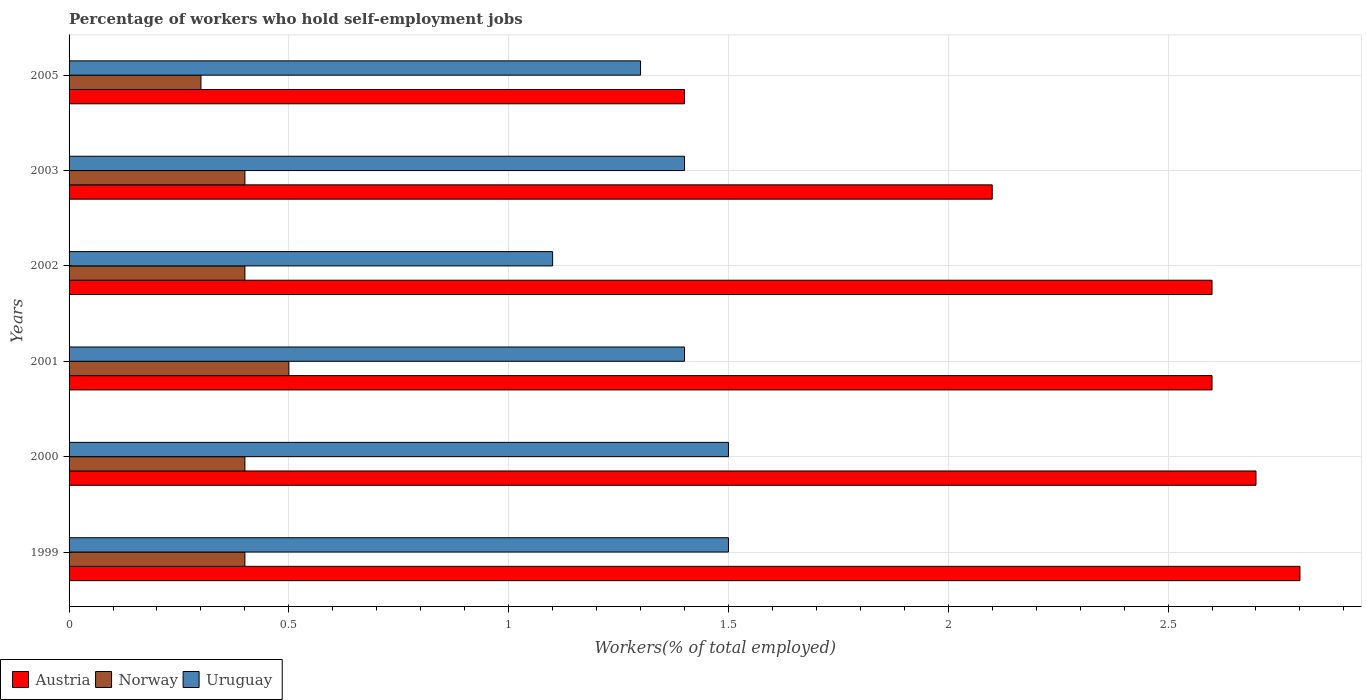How many different coloured bars are there?
Ensure brevity in your answer.  3. Are the number of bars on each tick of the Y-axis equal?
Your response must be concise. Yes. How many bars are there on the 2nd tick from the top?
Offer a terse response. 3. How many bars are there on the 3rd tick from the bottom?
Your answer should be compact. 3. What is the percentage of self-employed workers in Norway in 2002?
Offer a very short reply. 0.4. Across all years, what is the maximum percentage of self-employed workers in Norway?
Make the answer very short. 0.5. Across all years, what is the minimum percentage of self-employed workers in Uruguay?
Your answer should be very brief. 1.1. In which year was the percentage of self-employed workers in Austria maximum?
Make the answer very short. 1999. In which year was the percentage of self-employed workers in Austria minimum?
Give a very brief answer. 2005. What is the total percentage of self-employed workers in Austria in the graph?
Your answer should be compact. 14.2. What is the difference between the percentage of self-employed workers in Uruguay in 2001 and that in 2005?
Provide a succinct answer. 0.1. What is the difference between the percentage of self-employed workers in Norway in 2005 and the percentage of self-employed workers in Austria in 2002?
Give a very brief answer. -2.3. What is the average percentage of self-employed workers in Norway per year?
Your response must be concise. 0.4. In the year 2005, what is the difference between the percentage of self-employed workers in Norway and percentage of self-employed workers in Uruguay?
Keep it short and to the point. -1. What is the difference between the highest and the lowest percentage of self-employed workers in Uruguay?
Your response must be concise. 0.4. In how many years, is the percentage of self-employed workers in Uruguay greater than the average percentage of self-employed workers in Uruguay taken over all years?
Your answer should be very brief. 4. Is the sum of the percentage of self-employed workers in Norway in 2000 and 2001 greater than the maximum percentage of self-employed workers in Austria across all years?
Offer a very short reply. No. What does the 2nd bar from the top in 2001 represents?
Provide a short and direct response. Norway. What does the 1st bar from the bottom in 2002 represents?
Offer a very short reply. Austria. Are all the bars in the graph horizontal?
Provide a short and direct response. Yes. How many years are there in the graph?
Make the answer very short. 6. Are the values on the major ticks of X-axis written in scientific E-notation?
Make the answer very short. No. Where does the legend appear in the graph?
Give a very brief answer. Bottom left. How are the legend labels stacked?
Offer a very short reply. Horizontal. What is the title of the graph?
Your answer should be very brief. Percentage of workers who hold self-employment jobs. Does "Czech Republic" appear as one of the legend labels in the graph?
Keep it short and to the point. No. What is the label or title of the X-axis?
Give a very brief answer. Workers(% of total employed). What is the Workers(% of total employed) of Austria in 1999?
Your answer should be very brief. 2.8. What is the Workers(% of total employed) of Norway in 1999?
Keep it short and to the point. 0.4. What is the Workers(% of total employed) in Uruguay in 1999?
Give a very brief answer. 1.5. What is the Workers(% of total employed) of Austria in 2000?
Make the answer very short. 2.7. What is the Workers(% of total employed) of Norway in 2000?
Ensure brevity in your answer.  0.4. What is the Workers(% of total employed) in Austria in 2001?
Your response must be concise. 2.6. What is the Workers(% of total employed) of Norway in 2001?
Your answer should be very brief. 0.5. What is the Workers(% of total employed) in Uruguay in 2001?
Your answer should be compact. 1.4. What is the Workers(% of total employed) of Austria in 2002?
Ensure brevity in your answer.  2.6. What is the Workers(% of total employed) in Norway in 2002?
Keep it short and to the point. 0.4. What is the Workers(% of total employed) in Uruguay in 2002?
Your response must be concise. 1.1. What is the Workers(% of total employed) in Austria in 2003?
Provide a succinct answer. 2.1. What is the Workers(% of total employed) of Norway in 2003?
Provide a short and direct response. 0.4. What is the Workers(% of total employed) in Uruguay in 2003?
Give a very brief answer. 1.4. What is the Workers(% of total employed) in Austria in 2005?
Offer a very short reply. 1.4. What is the Workers(% of total employed) in Norway in 2005?
Give a very brief answer. 0.3. What is the Workers(% of total employed) in Uruguay in 2005?
Offer a very short reply. 1.3. Across all years, what is the maximum Workers(% of total employed) of Austria?
Keep it short and to the point. 2.8. Across all years, what is the maximum Workers(% of total employed) of Uruguay?
Make the answer very short. 1.5. Across all years, what is the minimum Workers(% of total employed) in Austria?
Ensure brevity in your answer.  1.4. Across all years, what is the minimum Workers(% of total employed) of Norway?
Ensure brevity in your answer.  0.3. Across all years, what is the minimum Workers(% of total employed) of Uruguay?
Ensure brevity in your answer.  1.1. What is the total Workers(% of total employed) of Austria in the graph?
Give a very brief answer. 14.2. What is the difference between the Workers(% of total employed) in Norway in 1999 and that in 2000?
Offer a terse response. 0. What is the difference between the Workers(% of total employed) of Austria in 1999 and that in 2002?
Ensure brevity in your answer.  0.2. What is the difference between the Workers(% of total employed) of Uruguay in 1999 and that in 2002?
Offer a terse response. 0.4. What is the difference between the Workers(% of total employed) of Austria in 1999 and that in 2003?
Make the answer very short. 0.7. What is the difference between the Workers(% of total employed) of Norway in 1999 and that in 2003?
Make the answer very short. 0. What is the difference between the Workers(% of total employed) of Uruguay in 1999 and that in 2005?
Provide a succinct answer. 0.2. What is the difference between the Workers(% of total employed) in Norway in 2000 and that in 2001?
Keep it short and to the point. -0.1. What is the difference between the Workers(% of total employed) in Norway in 2000 and that in 2002?
Provide a short and direct response. 0. What is the difference between the Workers(% of total employed) of Uruguay in 2000 and that in 2003?
Your answer should be very brief. 0.1. What is the difference between the Workers(% of total employed) in Austria in 2000 and that in 2005?
Provide a short and direct response. 1.3. What is the difference between the Workers(% of total employed) of Norway in 2000 and that in 2005?
Your answer should be compact. 0.1. What is the difference between the Workers(% of total employed) of Austria in 2001 and that in 2002?
Provide a succinct answer. 0. What is the difference between the Workers(% of total employed) of Norway in 2001 and that in 2002?
Give a very brief answer. 0.1. What is the difference between the Workers(% of total employed) in Austria in 2001 and that in 2005?
Your answer should be compact. 1.2. What is the difference between the Workers(% of total employed) in Austria in 2002 and that in 2003?
Your answer should be compact. 0.5. What is the difference between the Workers(% of total employed) of Norway in 2002 and that in 2003?
Your answer should be compact. 0. What is the difference between the Workers(% of total employed) in Uruguay in 2002 and that in 2003?
Offer a very short reply. -0.3. What is the difference between the Workers(% of total employed) in Norway in 2002 and that in 2005?
Give a very brief answer. 0.1. What is the difference between the Workers(% of total employed) in Uruguay in 2002 and that in 2005?
Offer a terse response. -0.2. What is the difference between the Workers(% of total employed) in Austria in 2003 and that in 2005?
Your response must be concise. 0.7. What is the difference between the Workers(% of total employed) of Austria in 1999 and the Workers(% of total employed) of Norway in 2000?
Offer a terse response. 2.4. What is the difference between the Workers(% of total employed) of Austria in 1999 and the Workers(% of total employed) of Uruguay in 2000?
Give a very brief answer. 1.3. What is the difference between the Workers(% of total employed) of Austria in 1999 and the Workers(% of total employed) of Uruguay in 2001?
Your answer should be compact. 1.4. What is the difference between the Workers(% of total employed) in Norway in 1999 and the Workers(% of total employed) in Uruguay in 2001?
Give a very brief answer. -1. What is the difference between the Workers(% of total employed) of Austria in 1999 and the Workers(% of total employed) of Norway in 2002?
Your answer should be very brief. 2.4. What is the difference between the Workers(% of total employed) of Austria in 1999 and the Workers(% of total employed) of Uruguay in 2002?
Provide a short and direct response. 1.7. What is the difference between the Workers(% of total employed) of Norway in 1999 and the Workers(% of total employed) of Uruguay in 2003?
Your response must be concise. -1. What is the difference between the Workers(% of total employed) of Austria in 1999 and the Workers(% of total employed) of Uruguay in 2005?
Provide a short and direct response. 1.5. What is the difference between the Workers(% of total employed) in Austria in 2000 and the Workers(% of total employed) in Uruguay in 2001?
Your response must be concise. 1.3. What is the difference between the Workers(% of total employed) in Norway in 2000 and the Workers(% of total employed) in Uruguay in 2001?
Offer a very short reply. -1. What is the difference between the Workers(% of total employed) in Austria in 2000 and the Workers(% of total employed) in Uruguay in 2002?
Provide a short and direct response. 1.6. What is the difference between the Workers(% of total employed) in Austria in 2000 and the Workers(% of total employed) in Norway in 2003?
Your answer should be compact. 2.3. What is the difference between the Workers(% of total employed) of Austria in 2000 and the Workers(% of total employed) of Uruguay in 2005?
Ensure brevity in your answer.  1.4. What is the difference between the Workers(% of total employed) of Norway in 2001 and the Workers(% of total employed) of Uruguay in 2002?
Provide a short and direct response. -0.6. What is the difference between the Workers(% of total employed) in Austria in 2001 and the Workers(% of total employed) in Uruguay in 2003?
Offer a very short reply. 1.2. What is the difference between the Workers(% of total employed) of Austria in 2001 and the Workers(% of total employed) of Norway in 2005?
Give a very brief answer. 2.3. What is the difference between the Workers(% of total employed) of Austria in 2002 and the Workers(% of total employed) of Norway in 2003?
Ensure brevity in your answer.  2.2. What is the difference between the Workers(% of total employed) of Austria in 2002 and the Workers(% of total employed) of Uruguay in 2003?
Give a very brief answer. 1.2. What is the difference between the Workers(% of total employed) of Norway in 2002 and the Workers(% of total employed) of Uruguay in 2003?
Provide a succinct answer. -1. What is the difference between the Workers(% of total employed) in Austria in 2002 and the Workers(% of total employed) in Uruguay in 2005?
Your answer should be very brief. 1.3. What is the difference between the Workers(% of total employed) of Austria in 2003 and the Workers(% of total employed) of Norway in 2005?
Ensure brevity in your answer.  1.8. What is the difference between the Workers(% of total employed) in Norway in 2003 and the Workers(% of total employed) in Uruguay in 2005?
Your answer should be compact. -0.9. What is the average Workers(% of total employed) of Austria per year?
Your response must be concise. 2.37. What is the average Workers(% of total employed) in Norway per year?
Your answer should be very brief. 0.4. What is the average Workers(% of total employed) of Uruguay per year?
Give a very brief answer. 1.37. In the year 1999, what is the difference between the Workers(% of total employed) in Austria and Workers(% of total employed) in Norway?
Offer a very short reply. 2.4. In the year 1999, what is the difference between the Workers(% of total employed) in Norway and Workers(% of total employed) in Uruguay?
Your answer should be compact. -1.1. In the year 2000, what is the difference between the Workers(% of total employed) of Austria and Workers(% of total employed) of Uruguay?
Ensure brevity in your answer.  1.2. In the year 2003, what is the difference between the Workers(% of total employed) of Norway and Workers(% of total employed) of Uruguay?
Offer a very short reply. -1. In the year 2005, what is the difference between the Workers(% of total employed) in Austria and Workers(% of total employed) in Uruguay?
Your answer should be compact. 0.1. What is the ratio of the Workers(% of total employed) of Uruguay in 1999 to that in 2001?
Give a very brief answer. 1.07. What is the ratio of the Workers(% of total employed) in Austria in 1999 to that in 2002?
Offer a terse response. 1.08. What is the ratio of the Workers(% of total employed) of Norway in 1999 to that in 2002?
Provide a short and direct response. 1. What is the ratio of the Workers(% of total employed) of Uruguay in 1999 to that in 2002?
Ensure brevity in your answer.  1.36. What is the ratio of the Workers(% of total employed) in Norway in 1999 to that in 2003?
Offer a terse response. 1. What is the ratio of the Workers(% of total employed) in Uruguay in 1999 to that in 2003?
Your answer should be very brief. 1.07. What is the ratio of the Workers(% of total employed) in Uruguay in 1999 to that in 2005?
Ensure brevity in your answer.  1.15. What is the ratio of the Workers(% of total employed) of Austria in 2000 to that in 2001?
Keep it short and to the point. 1.04. What is the ratio of the Workers(% of total employed) in Norway in 2000 to that in 2001?
Provide a succinct answer. 0.8. What is the ratio of the Workers(% of total employed) of Uruguay in 2000 to that in 2001?
Give a very brief answer. 1.07. What is the ratio of the Workers(% of total employed) of Norway in 2000 to that in 2002?
Your answer should be compact. 1. What is the ratio of the Workers(% of total employed) of Uruguay in 2000 to that in 2002?
Provide a succinct answer. 1.36. What is the ratio of the Workers(% of total employed) of Uruguay in 2000 to that in 2003?
Keep it short and to the point. 1.07. What is the ratio of the Workers(% of total employed) of Austria in 2000 to that in 2005?
Offer a terse response. 1.93. What is the ratio of the Workers(% of total employed) in Uruguay in 2000 to that in 2005?
Keep it short and to the point. 1.15. What is the ratio of the Workers(% of total employed) in Austria in 2001 to that in 2002?
Provide a succinct answer. 1. What is the ratio of the Workers(% of total employed) of Norway in 2001 to that in 2002?
Offer a terse response. 1.25. What is the ratio of the Workers(% of total employed) in Uruguay in 2001 to that in 2002?
Provide a short and direct response. 1.27. What is the ratio of the Workers(% of total employed) of Austria in 2001 to that in 2003?
Keep it short and to the point. 1.24. What is the ratio of the Workers(% of total employed) of Uruguay in 2001 to that in 2003?
Make the answer very short. 1. What is the ratio of the Workers(% of total employed) in Austria in 2001 to that in 2005?
Ensure brevity in your answer.  1.86. What is the ratio of the Workers(% of total employed) of Austria in 2002 to that in 2003?
Your answer should be compact. 1.24. What is the ratio of the Workers(% of total employed) of Norway in 2002 to that in 2003?
Your answer should be very brief. 1. What is the ratio of the Workers(% of total employed) of Uruguay in 2002 to that in 2003?
Make the answer very short. 0.79. What is the ratio of the Workers(% of total employed) in Austria in 2002 to that in 2005?
Offer a very short reply. 1.86. What is the ratio of the Workers(% of total employed) of Uruguay in 2002 to that in 2005?
Your answer should be compact. 0.85. What is the ratio of the Workers(% of total employed) of Norway in 2003 to that in 2005?
Ensure brevity in your answer.  1.33. What is the ratio of the Workers(% of total employed) in Uruguay in 2003 to that in 2005?
Your answer should be very brief. 1.08. What is the difference between the highest and the lowest Workers(% of total employed) in Austria?
Your answer should be very brief. 1.4. What is the difference between the highest and the lowest Workers(% of total employed) in Norway?
Make the answer very short. 0.2. 